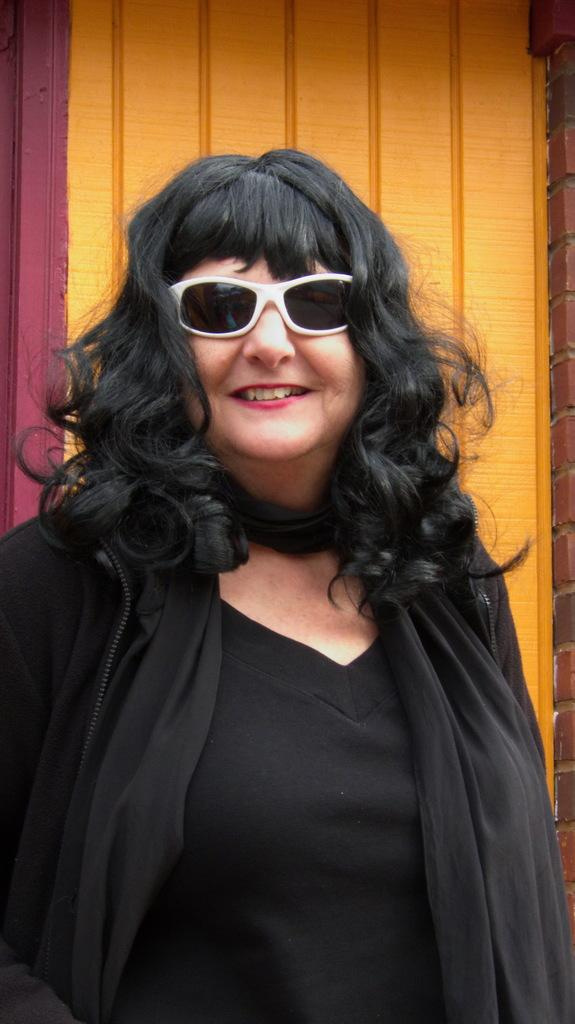What is the main subject of the image? The main subject of the image is a woman. What is the woman wearing in the image? The woman is wearing a black dress and goggles. What is the woman's facial expression in the image? The woman is smiling in the image. What is the woman doing in the image? The woman is giving a pose for the picture. What can be seen in the background of the image? There is a wall visible in the background of the image. What type of faucet can be seen in the image? There is no faucet present in the image. What flavor of gum is the woman chewing in the image? The image does not show the woman chewing gum, and therefore no flavor can be determined. 